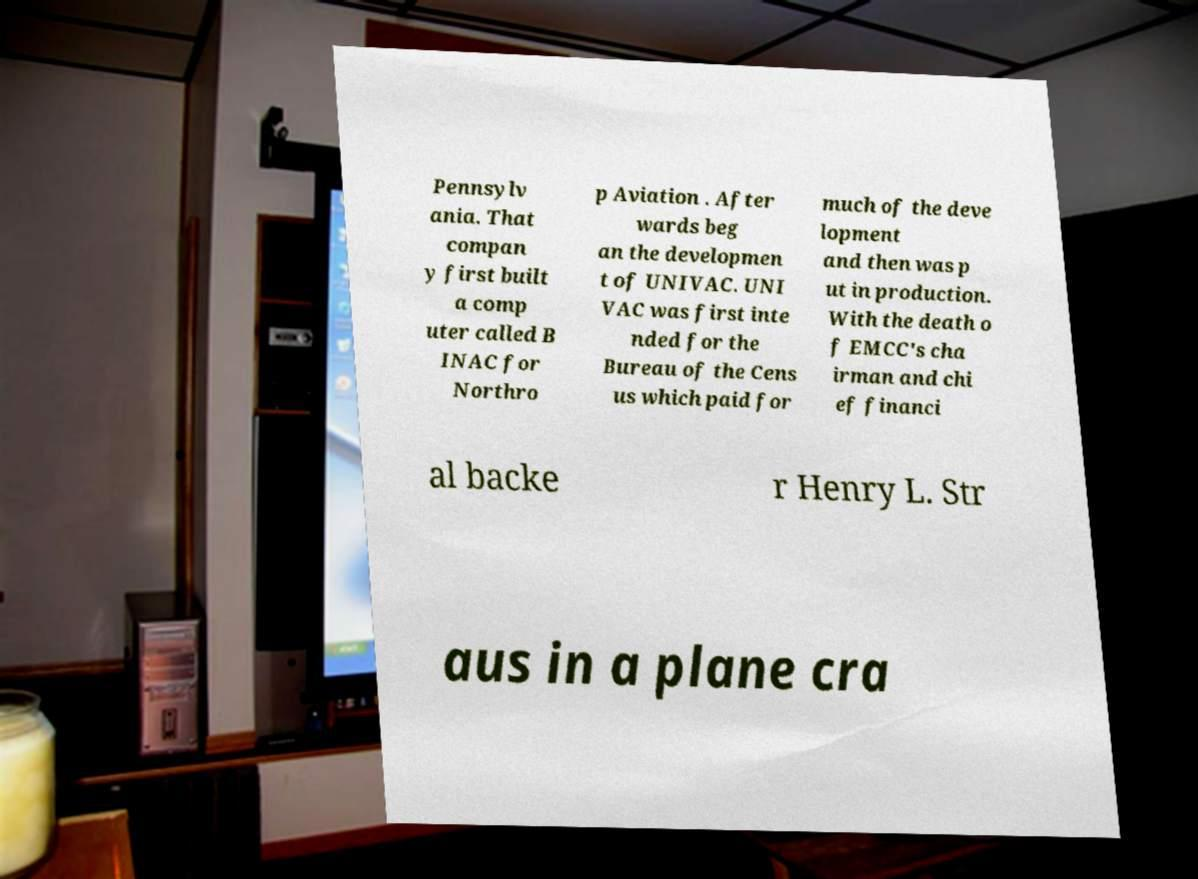Could you assist in decoding the text presented in this image and type it out clearly? Pennsylv ania. That compan y first built a comp uter called B INAC for Northro p Aviation . After wards beg an the developmen t of UNIVAC. UNI VAC was first inte nded for the Bureau of the Cens us which paid for much of the deve lopment and then was p ut in production. With the death o f EMCC's cha irman and chi ef financi al backe r Henry L. Str aus in a plane cra 